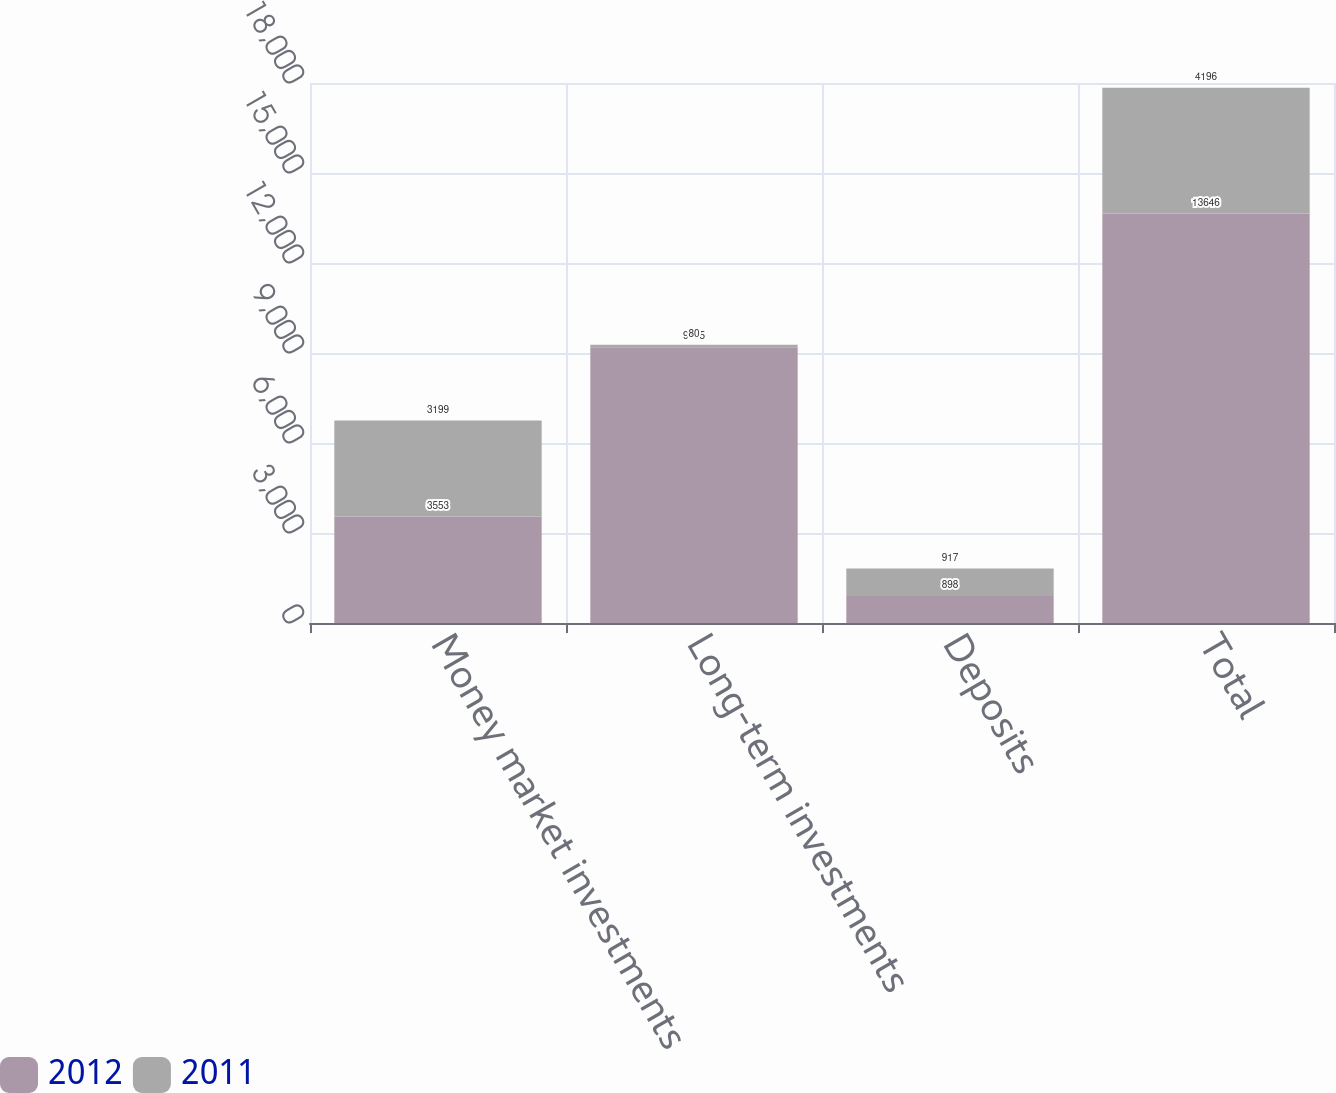<chart> <loc_0><loc_0><loc_500><loc_500><stacked_bar_chart><ecel><fcel>Money market investments<fcel>Long-term investments<fcel>Deposits<fcel>Total<nl><fcel>2012<fcel>3553<fcel>9195<fcel>898<fcel>13646<nl><fcel>2011<fcel>3199<fcel>80<fcel>917<fcel>4196<nl></chart> 